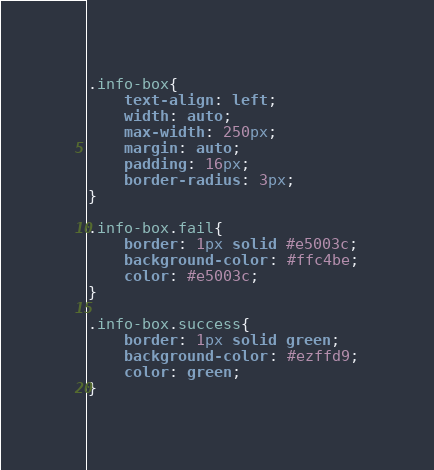Convert code to text. <code><loc_0><loc_0><loc_500><loc_500><_CSS_>.info-box{
    text-align: left;
    width: auto;
    max-width: 250px;
    margin: auto;
    padding: 16px;
    border-radius: 3px;
}

.info-box.fail{
    border: 1px solid #e5003c;
    background-color: #ffc4be;
    color: #e5003c;
}

.info-box.success{
    border: 1px solid green;
    background-color: #ezffd9;
    color: green;
}</code> 